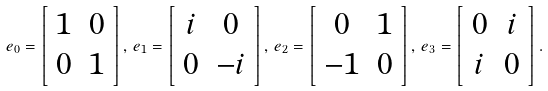Convert formula to latex. <formula><loc_0><loc_0><loc_500><loc_500>e _ { 0 } = \left [ \begin{array} { c c } 1 & 0 \\ 0 & 1 \end{array} \right ] , \, e _ { 1 } = \left [ \begin{array} { c c } i & 0 \\ 0 & - i \end{array} \right ] , \, e _ { 2 } = \left [ \begin{array} { c c } 0 & 1 \\ - 1 & 0 \end{array} \right ] , \, e _ { 3 } = \left [ \begin{array} { c c } 0 & i \\ i & 0 \end{array} \right ] .</formula> 